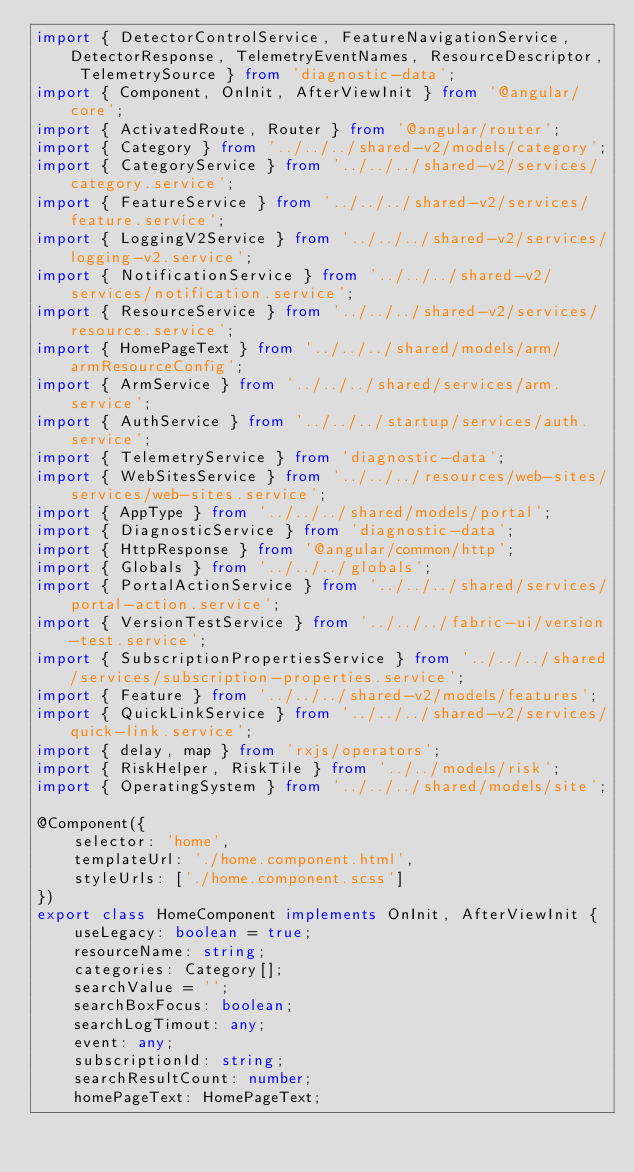<code> <loc_0><loc_0><loc_500><loc_500><_TypeScript_>import { DetectorControlService, FeatureNavigationService, DetectorResponse, TelemetryEventNames, ResourceDescriptor, TelemetrySource } from 'diagnostic-data';
import { Component, OnInit, AfterViewInit } from '@angular/core';
import { ActivatedRoute, Router } from '@angular/router';
import { Category } from '../../../shared-v2/models/category';
import { CategoryService } from '../../../shared-v2/services/category.service';
import { FeatureService } from '../../../shared-v2/services/feature.service';
import { LoggingV2Service } from '../../../shared-v2/services/logging-v2.service';
import { NotificationService } from '../../../shared-v2/services/notification.service';
import { ResourceService } from '../../../shared-v2/services/resource.service';
import { HomePageText } from '../../../shared/models/arm/armResourceConfig';
import { ArmService } from '../../../shared/services/arm.service';
import { AuthService } from '../../../startup/services/auth.service';
import { TelemetryService } from 'diagnostic-data';
import { WebSitesService } from '../../../resources/web-sites/services/web-sites.service';
import { AppType } from '../../../shared/models/portal';
import { DiagnosticService } from 'diagnostic-data';
import { HttpResponse } from '@angular/common/http';
import { Globals } from '../../../globals';
import { PortalActionService } from '../../../shared/services/portal-action.service';
import { VersionTestService } from '../../../fabric-ui/version-test.service';
import { SubscriptionPropertiesService } from '../../../shared/services/subscription-properties.service';
import { Feature } from '../../../shared-v2/models/features';
import { QuickLinkService } from '../../../shared-v2/services/quick-link.service';
import { delay, map } from 'rxjs/operators';
import { RiskHelper, RiskTile } from '../../models/risk';
import { OperatingSystem } from '../../../shared/models/site';

@Component({
    selector: 'home',
    templateUrl: './home.component.html',
    styleUrls: ['./home.component.scss']
})
export class HomeComponent implements OnInit, AfterViewInit {
    useLegacy: boolean = true;
    resourceName: string;
    categories: Category[];
    searchValue = '';
    searchBoxFocus: boolean;
    searchLogTimout: any;
    event: any;
    subscriptionId: string;
    searchResultCount: number;
    homePageText: HomePageText;</code> 